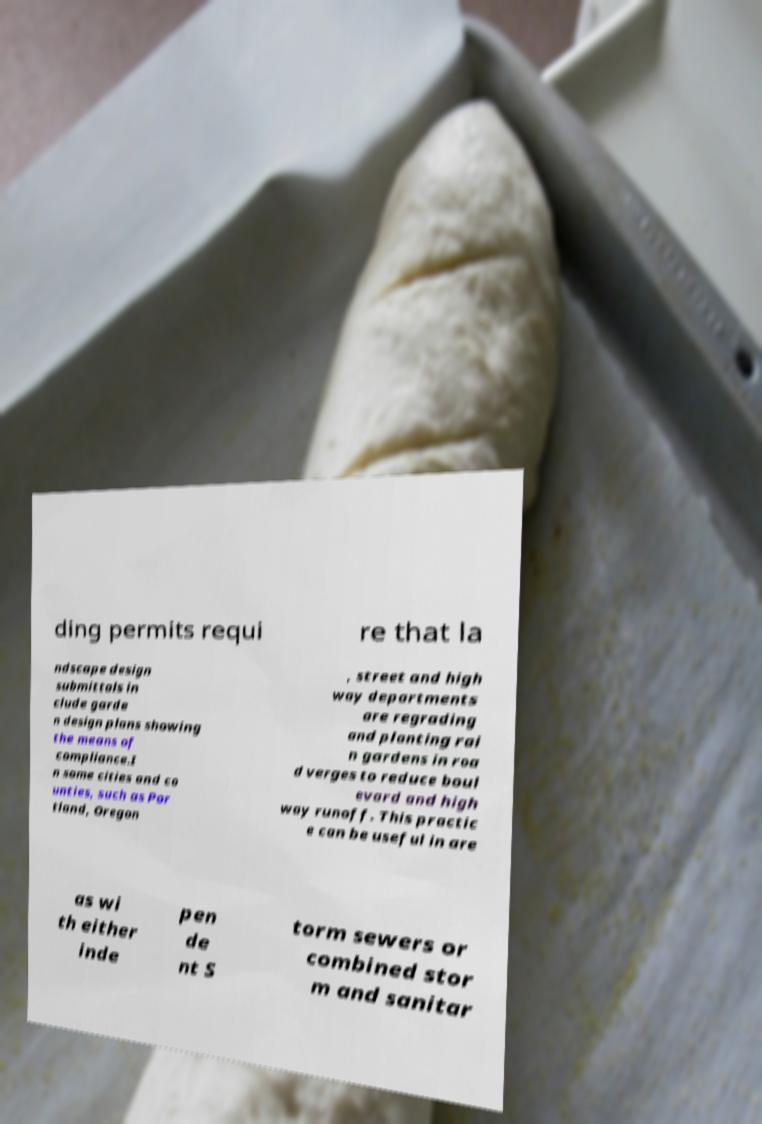Can you accurately transcribe the text from the provided image for me? ding permits requi re that la ndscape design submittals in clude garde n design plans showing the means of compliance.I n some cities and co unties, such as Por tland, Oregon , street and high way departments are regrading and planting rai n gardens in roa d verges to reduce boul evard and high way runoff. This practic e can be useful in are as wi th either inde pen de nt S torm sewers or combined stor m and sanitar 